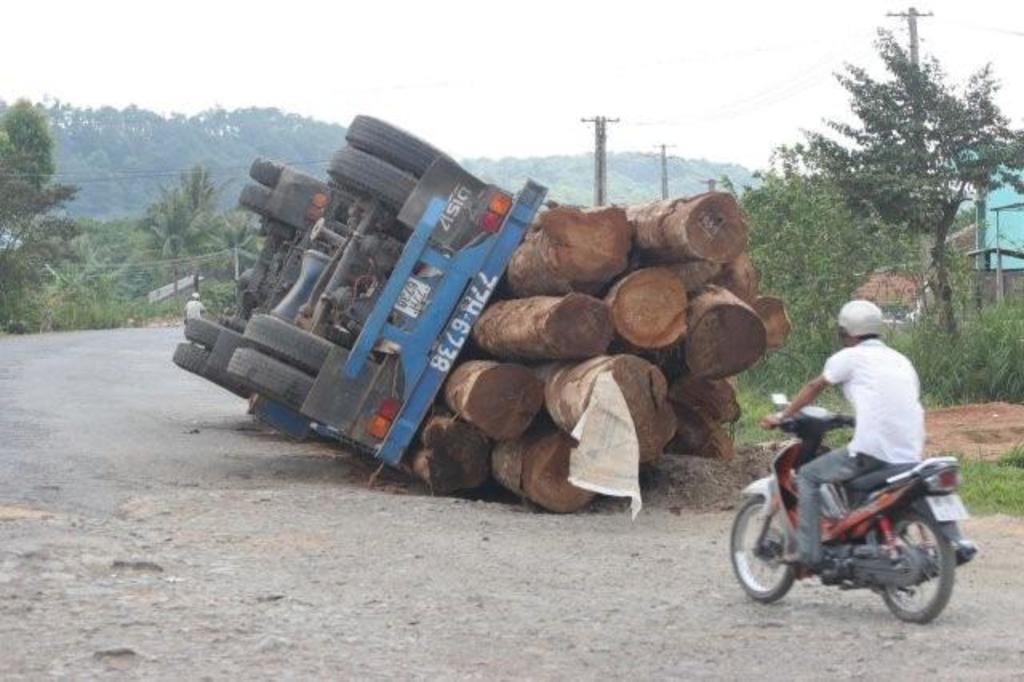What is the man in the image doing? The man is riding a bike in the image. What else can be seen in the image besides the man? There is a vehicle and branches visible in the image. What is located at the back side of the image? There is a tree and a building at the back side of the image. What type of stone is being processed in the lunchroom in the image? There is no stone or lunchroom present in the image. 